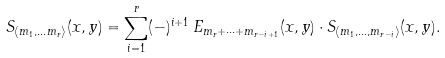Convert formula to latex. <formula><loc_0><loc_0><loc_500><loc_500>S _ { \langle m _ { 1 } , \dots m _ { r } \rangle } ( x , y ) = \sum _ { i = 1 } ^ { r } ( - ) ^ { i + 1 } \, E _ { m _ { r } + \dots + m _ { r - i + 1 } } ( x , y ) \cdot S _ { \langle m _ { 1 } , \dots , m _ { r - i } \rangle } ( x , y ) .</formula> 